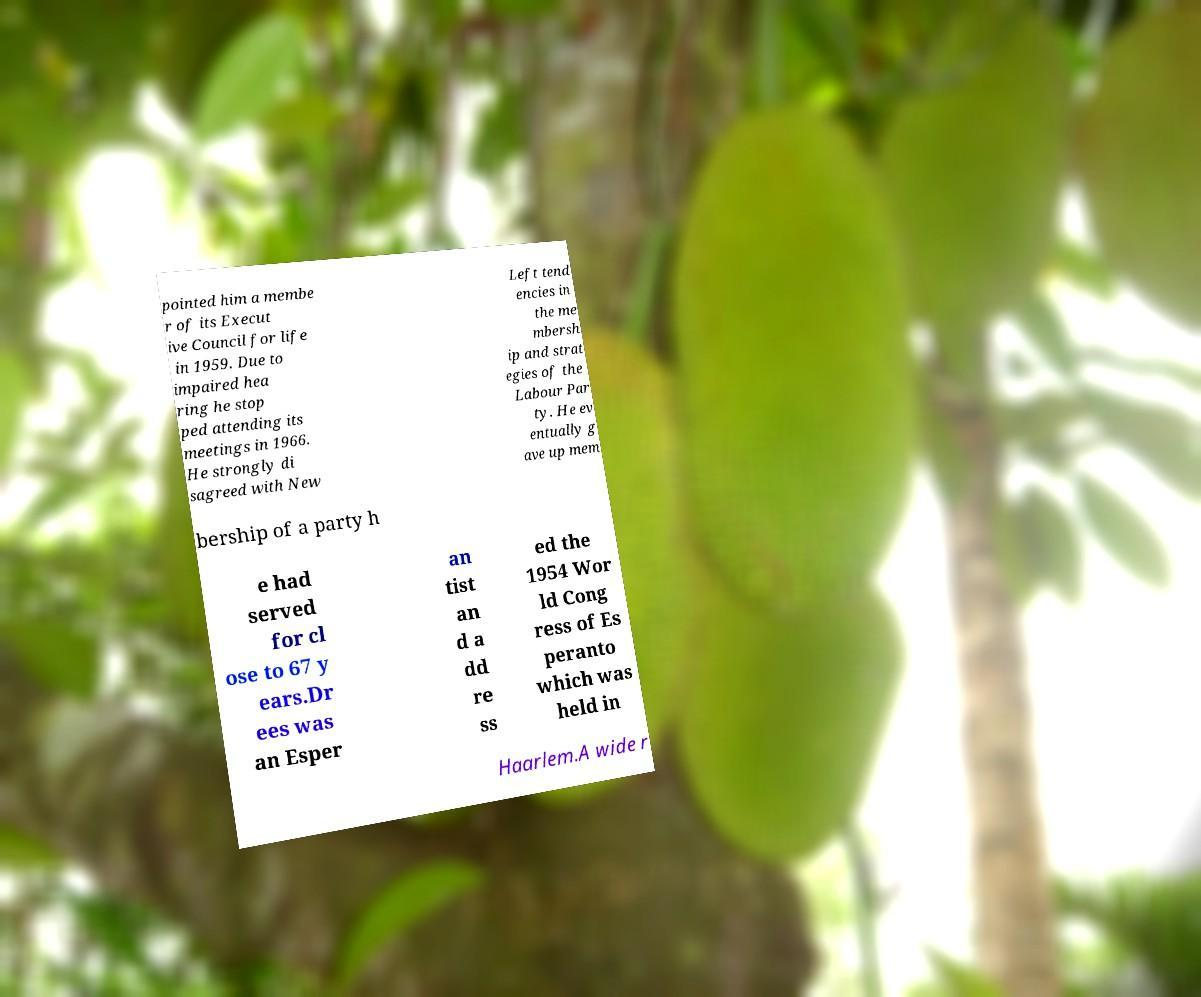I need the written content from this picture converted into text. Can you do that? pointed him a membe r of its Execut ive Council for life in 1959. Due to impaired hea ring he stop ped attending its meetings in 1966. He strongly di sagreed with New Left tend encies in the me mbersh ip and strat egies of the Labour Par ty. He ev entually g ave up mem bership of a party h e had served for cl ose to 67 y ears.Dr ees was an Esper an tist an d a dd re ss ed the 1954 Wor ld Cong ress of Es peranto which was held in Haarlem.A wide r 